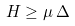Convert formula to latex. <formula><loc_0><loc_0><loc_500><loc_500>H \geq \mu \, \Delta</formula> 